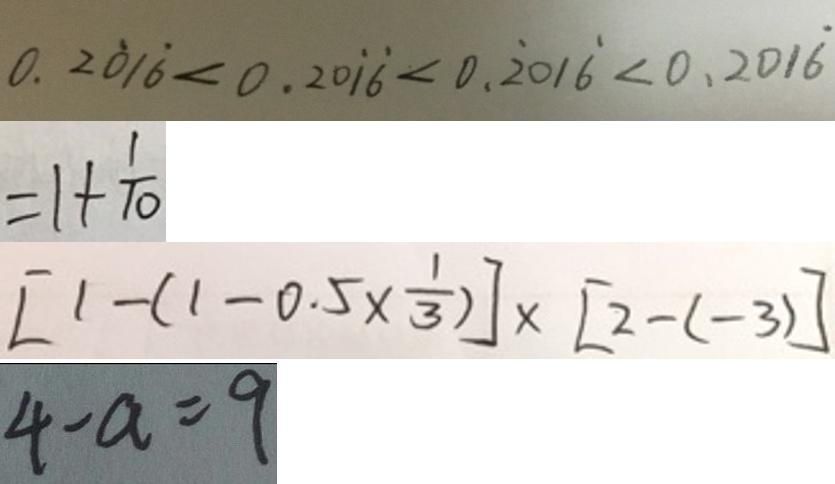Convert formula to latex. <formula><loc_0><loc_0><loc_500><loc_500>0 . 2 \dot { 0 } 1 \dot { 6 } < 0 . 2 0 \dot { 1 } \dot { 6 } < 0 . \dot { 2 } 0 1 \dot { 6 } < 0 . 2 0 1 \dot { 6 } 
 = 1 + \frac { 1 } { 1 0 } 
 [ 1 - ( 1 - 0 . 5 \times \frac { 1 } { 3 } ) ] \times [ 2 - ( - 3 ) ] 
 4 - a = 9</formula> 